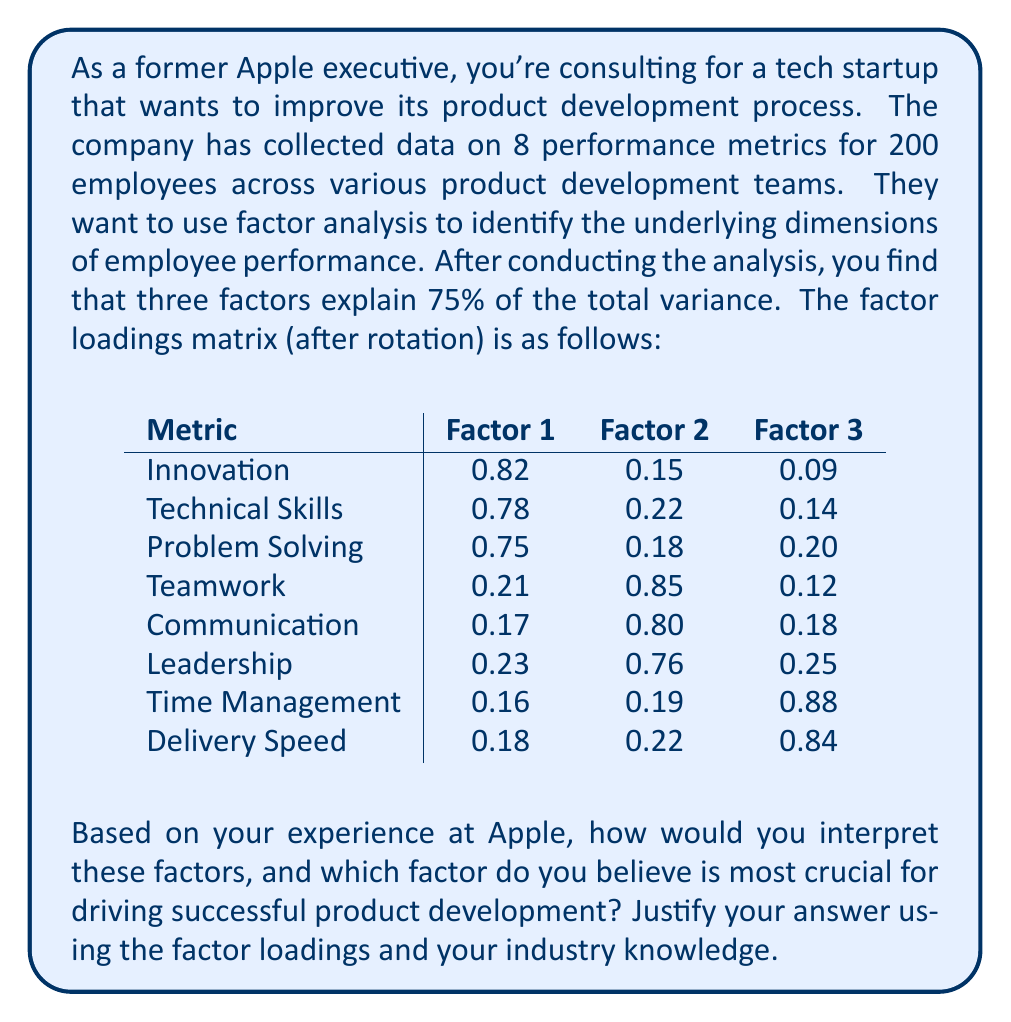Provide a solution to this math problem. To interpret the factors and determine which is most crucial for successful product development, we need to analyze the factor loadings matrix and apply industry knowledge. Let's break down the process:

1. Interpret the factors:

Factor 1:
- High loadings on Innovation (0.82), Technical Skills (0.78), and Problem Solving (0.75)
- This factor represents the technical and creative aspects of product development
- We can label this factor as "Technical Innovation"

Factor 2:
- High loadings on Teamwork (0.85), Communication (0.80), and Leadership (0.76)
- This factor represents the collaborative and interpersonal aspects of product development
- We can label this factor as "Collaboration and Leadership"

Factor 3:
- High loadings on Time Management (0.88) and Delivery Speed (0.84)
- This factor represents the efficiency and productivity aspects of product development
- We can label this factor as "Execution Efficiency"

2. Determine the most crucial factor:

To decide which factor is most crucial for driving successful product development, we need to consider the nature of product development in the tech industry and draw from Apple's experience:

a) Technical Innovation (Factor 1):
- Essential for creating groundbreaking products
- Aligns with Apple's focus on innovation and cutting-edge technology
- Crucial for maintaining a competitive edge in the market

b) Collaboration and Leadership (Factor 2):
- Important for coordinating complex projects and fostering a creative environment
- Reflects Apple's emphasis on cross-functional teams and design-driven development
- Necessary for translating innovative ideas into viable products

c) Execution Efficiency (Factor 3):
- Vital for meeting deadlines and managing resources effectively
- Aligns with Apple's ability to deliver high-quality products on schedule
- Critical for maintaining market momentum and customer satisfaction

3. Justification:

Based on Apple's success and industry trends, Factor 1 (Technical Innovation) can be considered the most crucial for driving successful product development. Here's why:

- Innovation is the primary driver of success in the tech industry, especially for companies aiming to create disruptive products like Apple did with the iPhone, iPad, and Apple Watch.
- The high factor loadings for Innovation (0.82), Technical Skills (0.78), and Problem Solving (0.75) indicate that these metrics are closely related and form a strong foundation for product development.
- Apple's history shows that groundbreaking innovations often lead to market leadership and long-term success, even if they require significant collaboration (Factor 2) and efficient execution (Factor 3) to bring them to market.
- In a rapidly evolving tech landscape, the ability to innovate and solve complex technical problems is paramount for staying ahead of competitors and creating products that resonate with consumers.

While all three factors are important, Technical Innovation serves as the primary catalyst for successful product development, particularly in companies aiming to emulate Apple's success in creating industry-defining products.
Answer: Factor 1 (Technical Innovation) is the most crucial for driving successful product development. This factor, with high loadings on Innovation (0.82), Technical Skills (0.78), and Problem Solving (0.75), represents the core capabilities needed to create groundbreaking products in the tech industry. Based on Apple's experience, technical innovation is the primary driver of market leadership and long-term success, even though collaboration and efficient execution are also important in bringing innovative ideas to market. 